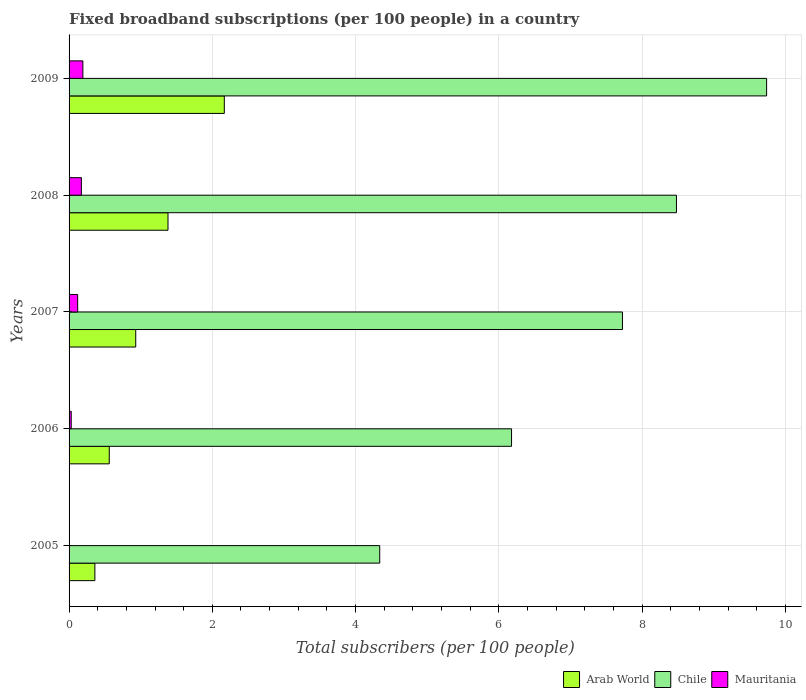Are the number of bars on each tick of the Y-axis equal?
Offer a terse response. Yes. What is the label of the 4th group of bars from the top?
Keep it short and to the point. 2006. What is the number of broadband subscriptions in Mauritania in 2007?
Provide a succinct answer. 0.12. Across all years, what is the maximum number of broadband subscriptions in Arab World?
Your response must be concise. 2.17. Across all years, what is the minimum number of broadband subscriptions in Mauritania?
Your answer should be very brief. 0.01. In which year was the number of broadband subscriptions in Mauritania maximum?
Offer a terse response. 2009. What is the total number of broadband subscriptions in Arab World in the graph?
Keep it short and to the point. 5.4. What is the difference between the number of broadband subscriptions in Mauritania in 2005 and that in 2009?
Make the answer very short. -0.19. What is the difference between the number of broadband subscriptions in Mauritania in 2008 and the number of broadband subscriptions in Arab World in 2007?
Provide a succinct answer. -0.76. What is the average number of broadband subscriptions in Mauritania per year?
Keep it short and to the point. 0.1. In the year 2009, what is the difference between the number of broadband subscriptions in Mauritania and number of broadband subscriptions in Arab World?
Keep it short and to the point. -1.97. In how many years, is the number of broadband subscriptions in Mauritania greater than 8.8 ?
Your answer should be very brief. 0. What is the ratio of the number of broadband subscriptions in Mauritania in 2007 to that in 2009?
Your answer should be compact. 0.62. Is the number of broadband subscriptions in Mauritania in 2006 less than that in 2007?
Provide a short and direct response. Yes. What is the difference between the highest and the second highest number of broadband subscriptions in Mauritania?
Provide a succinct answer. 0.02. What is the difference between the highest and the lowest number of broadband subscriptions in Chile?
Offer a terse response. 5.4. In how many years, is the number of broadband subscriptions in Chile greater than the average number of broadband subscriptions in Chile taken over all years?
Offer a terse response. 3. What does the 1st bar from the top in 2009 represents?
Make the answer very short. Mauritania. What does the 2nd bar from the bottom in 2006 represents?
Give a very brief answer. Chile. Is it the case that in every year, the sum of the number of broadband subscriptions in Arab World and number of broadband subscriptions in Chile is greater than the number of broadband subscriptions in Mauritania?
Offer a terse response. Yes. How many bars are there?
Your answer should be very brief. 15. How many years are there in the graph?
Your answer should be compact. 5. What is the difference between two consecutive major ticks on the X-axis?
Your answer should be compact. 2. Are the values on the major ticks of X-axis written in scientific E-notation?
Provide a short and direct response. No. How many legend labels are there?
Provide a short and direct response. 3. How are the legend labels stacked?
Give a very brief answer. Horizontal. What is the title of the graph?
Your response must be concise. Fixed broadband subscriptions (per 100 people) in a country. What is the label or title of the X-axis?
Offer a terse response. Total subscribers (per 100 people). What is the Total subscribers (per 100 people) in Arab World in 2005?
Your answer should be compact. 0.36. What is the Total subscribers (per 100 people) of Chile in 2005?
Your answer should be compact. 4.34. What is the Total subscribers (per 100 people) of Mauritania in 2005?
Ensure brevity in your answer.  0.01. What is the Total subscribers (per 100 people) of Arab World in 2006?
Keep it short and to the point. 0.56. What is the Total subscribers (per 100 people) in Chile in 2006?
Your response must be concise. 6.18. What is the Total subscribers (per 100 people) of Mauritania in 2006?
Provide a short and direct response. 0.03. What is the Total subscribers (per 100 people) in Arab World in 2007?
Give a very brief answer. 0.93. What is the Total subscribers (per 100 people) in Chile in 2007?
Ensure brevity in your answer.  7.73. What is the Total subscribers (per 100 people) of Mauritania in 2007?
Keep it short and to the point. 0.12. What is the Total subscribers (per 100 people) of Arab World in 2008?
Provide a succinct answer. 1.38. What is the Total subscribers (per 100 people) of Chile in 2008?
Provide a short and direct response. 8.48. What is the Total subscribers (per 100 people) in Mauritania in 2008?
Offer a terse response. 0.17. What is the Total subscribers (per 100 people) in Arab World in 2009?
Your answer should be compact. 2.17. What is the Total subscribers (per 100 people) in Chile in 2009?
Provide a short and direct response. 9.74. What is the Total subscribers (per 100 people) of Mauritania in 2009?
Make the answer very short. 0.19. Across all years, what is the maximum Total subscribers (per 100 people) of Arab World?
Your response must be concise. 2.17. Across all years, what is the maximum Total subscribers (per 100 people) of Chile?
Your response must be concise. 9.74. Across all years, what is the maximum Total subscribers (per 100 people) of Mauritania?
Your answer should be very brief. 0.19. Across all years, what is the minimum Total subscribers (per 100 people) in Arab World?
Offer a terse response. 0.36. Across all years, what is the minimum Total subscribers (per 100 people) of Chile?
Provide a short and direct response. 4.34. Across all years, what is the minimum Total subscribers (per 100 people) in Mauritania?
Your answer should be compact. 0.01. What is the total Total subscribers (per 100 people) in Arab World in the graph?
Keep it short and to the point. 5.4. What is the total Total subscribers (per 100 people) of Chile in the graph?
Provide a short and direct response. 36.46. What is the total Total subscribers (per 100 people) of Mauritania in the graph?
Your answer should be very brief. 0.52. What is the difference between the Total subscribers (per 100 people) in Arab World in 2005 and that in 2006?
Make the answer very short. -0.2. What is the difference between the Total subscribers (per 100 people) of Chile in 2005 and that in 2006?
Your answer should be very brief. -1.84. What is the difference between the Total subscribers (per 100 people) of Mauritania in 2005 and that in 2006?
Provide a short and direct response. -0.02. What is the difference between the Total subscribers (per 100 people) of Arab World in 2005 and that in 2007?
Your response must be concise. -0.57. What is the difference between the Total subscribers (per 100 people) in Chile in 2005 and that in 2007?
Give a very brief answer. -3.39. What is the difference between the Total subscribers (per 100 people) of Mauritania in 2005 and that in 2007?
Give a very brief answer. -0.11. What is the difference between the Total subscribers (per 100 people) in Arab World in 2005 and that in 2008?
Offer a very short reply. -1.02. What is the difference between the Total subscribers (per 100 people) in Chile in 2005 and that in 2008?
Your answer should be very brief. -4.14. What is the difference between the Total subscribers (per 100 people) of Mauritania in 2005 and that in 2008?
Offer a very short reply. -0.17. What is the difference between the Total subscribers (per 100 people) in Arab World in 2005 and that in 2009?
Ensure brevity in your answer.  -1.81. What is the difference between the Total subscribers (per 100 people) of Chile in 2005 and that in 2009?
Give a very brief answer. -5.4. What is the difference between the Total subscribers (per 100 people) in Mauritania in 2005 and that in 2009?
Provide a short and direct response. -0.19. What is the difference between the Total subscribers (per 100 people) of Arab World in 2006 and that in 2007?
Keep it short and to the point. -0.37. What is the difference between the Total subscribers (per 100 people) in Chile in 2006 and that in 2007?
Keep it short and to the point. -1.55. What is the difference between the Total subscribers (per 100 people) of Mauritania in 2006 and that in 2007?
Offer a terse response. -0.09. What is the difference between the Total subscribers (per 100 people) of Arab World in 2006 and that in 2008?
Make the answer very short. -0.82. What is the difference between the Total subscribers (per 100 people) of Chile in 2006 and that in 2008?
Your answer should be very brief. -2.3. What is the difference between the Total subscribers (per 100 people) of Mauritania in 2006 and that in 2008?
Keep it short and to the point. -0.14. What is the difference between the Total subscribers (per 100 people) in Arab World in 2006 and that in 2009?
Your answer should be very brief. -1.61. What is the difference between the Total subscribers (per 100 people) of Chile in 2006 and that in 2009?
Offer a terse response. -3.56. What is the difference between the Total subscribers (per 100 people) in Mauritania in 2006 and that in 2009?
Provide a short and direct response. -0.16. What is the difference between the Total subscribers (per 100 people) of Arab World in 2007 and that in 2008?
Your answer should be compact. -0.45. What is the difference between the Total subscribers (per 100 people) of Chile in 2007 and that in 2008?
Provide a short and direct response. -0.75. What is the difference between the Total subscribers (per 100 people) of Mauritania in 2007 and that in 2008?
Make the answer very short. -0.05. What is the difference between the Total subscribers (per 100 people) in Arab World in 2007 and that in 2009?
Ensure brevity in your answer.  -1.24. What is the difference between the Total subscribers (per 100 people) of Chile in 2007 and that in 2009?
Offer a very short reply. -2.01. What is the difference between the Total subscribers (per 100 people) in Mauritania in 2007 and that in 2009?
Provide a succinct answer. -0.07. What is the difference between the Total subscribers (per 100 people) in Arab World in 2008 and that in 2009?
Ensure brevity in your answer.  -0.79. What is the difference between the Total subscribers (per 100 people) in Chile in 2008 and that in 2009?
Offer a very short reply. -1.26. What is the difference between the Total subscribers (per 100 people) in Mauritania in 2008 and that in 2009?
Ensure brevity in your answer.  -0.02. What is the difference between the Total subscribers (per 100 people) in Arab World in 2005 and the Total subscribers (per 100 people) in Chile in 2006?
Your response must be concise. -5.82. What is the difference between the Total subscribers (per 100 people) of Arab World in 2005 and the Total subscribers (per 100 people) of Mauritania in 2006?
Your response must be concise. 0.33. What is the difference between the Total subscribers (per 100 people) of Chile in 2005 and the Total subscribers (per 100 people) of Mauritania in 2006?
Provide a succinct answer. 4.31. What is the difference between the Total subscribers (per 100 people) of Arab World in 2005 and the Total subscribers (per 100 people) of Chile in 2007?
Keep it short and to the point. -7.37. What is the difference between the Total subscribers (per 100 people) in Arab World in 2005 and the Total subscribers (per 100 people) in Mauritania in 2007?
Offer a very short reply. 0.24. What is the difference between the Total subscribers (per 100 people) of Chile in 2005 and the Total subscribers (per 100 people) of Mauritania in 2007?
Make the answer very short. 4.22. What is the difference between the Total subscribers (per 100 people) of Arab World in 2005 and the Total subscribers (per 100 people) of Chile in 2008?
Provide a short and direct response. -8.12. What is the difference between the Total subscribers (per 100 people) of Arab World in 2005 and the Total subscribers (per 100 people) of Mauritania in 2008?
Provide a short and direct response. 0.19. What is the difference between the Total subscribers (per 100 people) in Chile in 2005 and the Total subscribers (per 100 people) in Mauritania in 2008?
Your answer should be compact. 4.17. What is the difference between the Total subscribers (per 100 people) of Arab World in 2005 and the Total subscribers (per 100 people) of Chile in 2009?
Give a very brief answer. -9.38. What is the difference between the Total subscribers (per 100 people) of Arab World in 2005 and the Total subscribers (per 100 people) of Mauritania in 2009?
Your answer should be compact. 0.17. What is the difference between the Total subscribers (per 100 people) of Chile in 2005 and the Total subscribers (per 100 people) of Mauritania in 2009?
Make the answer very short. 4.14. What is the difference between the Total subscribers (per 100 people) of Arab World in 2006 and the Total subscribers (per 100 people) of Chile in 2007?
Provide a short and direct response. -7.16. What is the difference between the Total subscribers (per 100 people) in Arab World in 2006 and the Total subscribers (per 100 people) in Mauritania in 2007?
Make the answer very short. 0.44. What is the difference between the Total subscribers (per 100 people) of Chile in 2006 and the Total subscribers (per 100 people) of Mauritania in 2007?
Keep it short and to the point. 6.06. What is the difference between the Total subscribers (per 100 people) of Arab World in 2006 and the Total subscribers (per 100 people) of Chile in 2008?
Ensure brevity in your answer.  -7.92. What is the difference between the Total subscribers (per 100 people) in Arab World in 2006 and the Total subscribers (per 100 people) in Mauritania in 2008?
Your answer should be compact. 0.39. What is the difference between the Total subscribers (per 100 people) of Chile in 2006 and the Total subscribers (per 100 people) of Mauritania in 2008?
Offer a very short reply. 6.01. What is the difference between the Total subscribers (per 100 people) in Arab World in 2006 and the Total subscribers (per 100 people) in Chile in 2009?
Your answer should be compact. -9.18. What is the difference between the Total subscribers (per 100 people) in Arab World in 2006 and the Total subscribers (per 100 people) in Mauritania in 2009?
Your response must be concise. 0.37. What is the difference between the Total subscribers (per 100 people) of Chile in 2006 and the Total subscribers (per 100 people) of Mauritania in 2009?
Your response must be concise. 5.98. What is the difference between the Total subscribers (per 100 people) of Arab World in 2007 and the Total subscribers (per 100 people) of Chile in 2008?
Keep it short and to the point. -7.55. What is the difference between the Total subscribers (per 100 people) in Arab World in 2007 and the Total subscribers (per 100 people) in Mauritania in 2008?
Make the answer very short. 0.76. What is the difference between the Total subscribers (per 100 people) in Chile in 2007 and the Total subscribers (per 100 people) in Mauritania in 2008?
Your answer should be very brief. 7.55. What is the difference between the Total subscribers (per 100 people) of Arab World in 2007 and the Total subscribers (per 100 people) of Chile in 2009?
Ensure brevity in your answer.  -8.81. What is the difference between the Total subscribers (per 100 people) of Arab World in 2007 and the Total subscribers (per 100 people) of Mauritania in 2009?
Give a very brief answer. 0.74. What is the difference between the Total subscribers (per 100 people) in Chile in 2007 and the Total subscribers (per 100 people) in Mauritania in 2009?
Ensure brevity in your answer.  7.53. What is the difference between the Total subscribers (per 100 people) of Arab World in 2008 and the Total subscribers (per 100 people) of Chile in 2009?
Give a very brief answer. -8.36. What is the difference between the Total subscribers (per 100 people) in Arab World in 2008 and the Total subscribers (per 100 people) in Mauritania in 2009?
Provide a short and direct response. 1.19. What is the difference between the Total subscribers (per 100 people) of Chile in 2008 and the Total subscribers (per 100 people) of Mauritania in 2009?
Your answer should be compact. 8.29. What is the average Total subscribers (per 100 people) in Arab World per year?
Your answer should be compact. 1.08. What is the average Total subscribers (per 100 people) of Chile per year?
Provide a short and direct response. 7.29. What is the average Total subscribers (per 100 people) in Mauritania per year?
Ensure brevity in your answer.  0.1. In the year 2005, what is the difference between the Total subscribers (per 100 people) of Arab World and Total subscribers (per 100 people) of Chile?
Keep it short and to the point. -3.98. In the year 2005, what is the difference between the Total subscribers (per 100 people) in Arab World and Total subscribers (per 100 people) in Mauritania?
Offer a terse response. 0.35. In the year 2005, what is the difference between the Total subscribers (per 100 people) of Chile and Total subscribers (per 100 people) of Mauritania?
Keep it short and to the point. 4.33. In the year 2006, what is the difference between the Total subscribers (per 100 people) of Arab World and Total subscribers (per 100 people) of Chile?
Offer a terse response. -5.62. In the year 2006, what is the difference between the Total subscribers (per 100 people) of Arab World and Total subscribers (per 100 people) of Mauritania?
Give a very brief answer. 0.53. In the year 2006, what is the difference between the Total subscribers (per 100 people) in Chile and Total subscribers (per 100 people) in Mauritania?
Offer a very short reply. 6.15. In the year 2007, what is the difference between the Total subscribers (per 100 people) in Arab World and Total subscribers (per 100 people) in Chile?
Offer a terse response. -6.8. In the year 2007, what is the difference between the Total subscribers (per 100 people) of Arab World and Total subscribers (per 100 people) of Mauritania?
Make the answer very short. 0.81. In the year 2007, what is the difference between the Total subscribers (per 100 people) of Chile and Total subscribers (per 100 people) of Mauritania?
Provide a succinct answer. 7.61. In the year 2008, what is the difference between the Total subscribers (per 100 people) in Arab World and Total subscribers (per 100 people) in Chile?
Ensure brevity in your answer.  -7.1. In the year 2008, what is the difference between the Total subscribers (per 100 people) of Arab World and Total subscribers (per 100 people) of Mauritania?
Offer a very short reply. 1.21. In the year 2008, what is the difference between the Total subscribers (per 100 people) in Chile and Total subscribers (per 100 people) in Mauritania?
Your response must be concise. 8.31. In the year 2009, what is the difference between the Total subscribers (per 100 people) of Arab World and Total subscribers (per 100 people) of Chile?
Your answer should be compact. -7.57. In the year 2009, what is the difference between the Total subscribers (per 100 people) in Arab World and Total subscribers (per 100 people) in Mauritania?
Ensure brevity in your answer.  1.97. In the year 2009, what is the difference between the Total subscribers (per 100 people) of Chile and Total subscribers (per 100 people) of Mauritania?
Provide a succinct answer. 9.55. What is the ratio of the Total subscribers (per 100 people) of Arab World in 2005 to that in 2006?
Keep it short and to the point. 0.64. What is the ratio of the Total subscribers (per 100 people) in Chile in 2005 to that in 2006?
Provide a short and direct response. 0.7. What is the ratio of the Total subscribers (per 100 people) in Mauritania in 2005 to that in 2006?
Ensure brevity in your answer.  0.17. What is the ratio of the Total subscribers (per 100 people) of Arab World in 2005 to that in 2007?
Provide a short and direct response. 0.39. What is the ratio of the Total subscribers (per 100 people) in Chile in 2005 to that in 2007?
Offer a terse response. 0.56. What is the ratio of the Total subscribers (per 100 people) of Mauritania in 2005 to that in 2007?
Your response must be concise. 0.04. What is the ratio of the Total subscribers (per 100 people) of Arab World in 2005 to that in 2008?
Keep it short and to the point. 0.26. What is the ratio of the Total subscribers (per 100 people) in Chile in 2005 to that in 2008?
Provide a succinct answer. 0.51. What is the ratio of the Total subscribers (per 100 people) in Mauritania in 2005 to that in 2008?
Offer a very short reply. 0.03. What is the ratio of the Total subscribers (per 100 people) of Arab World in 2005 to that in 2009?
Your answer should be very brief. 0.17. What is the ratio of the Total subscribers (per 100 people) in Chile in 2005 to that in 2009?
Provide a succinct answer. 0.45. What is the ratio of the Total subscribers (per 100 people) in Mauritania in 2005 to that in 2009?
Your answer should be very brief. 0.03. What is the ratio of the Total subscribers (per 100 people) of Arab World in 2006 to that in 2007?
Keep it short and to the point. 0.6. What is the ratio of the Total subscribers (per 100 people) of Chile in 2006 to that in 2007?
Ensure brevity in your answer.  0.8. What is the ratio of the Total subscribers (per 100 people) in Mauritania in 2006 to that in 2007?
Your answer should be very brief. 0.25. What is the ratio of the Total subscribers (per 100 people) in Arab World in 2006 to that in 2008?
Your response must be concise. 0.41. What is the ratio of the Total subscribers (per 100 people) of Chile in 2006 to that in 2008?
Offer a very short reply. 0.73. What is the ratio of the Total subscribers (per 100 people) in Mauritania in 2006 to that in 2008?
Make the answer very short. 0.18. What is the ratio of the Total subscribers (per 100 people) of Arab World in 2006 to that in 2009?
Provide a succinct answer. 0.26. What is the ratio of the Total subscribers (per 100 people) in Chile in 2006 to that in 2009?
Keep it short and to the point. 0.63. What is the ratio of the Total subscribers (per 100 people) in Mauritania in 2006 to that in 2009?
Ensure brevity in your answer.  0.16. What is the ratio of the Total subscribers (per 100 people) in Arab World in 2007 to that in 2008?
Your answer should be compact. 0.67. What is the ratio of the Total subscribers (per 100 people) of Chile in 2007 to that in 2008?
Your answer should be very brief. 0.91. What is the ratio of the Total subscribers (per 100 people) in Mauritania in 2007 to that in 2008?
Offer a very short reply. 0.7. What is the ratio of the Total subscribers (per 100 people) in Arab World in 2007 to that in 2009?
Keep it short and to the point. 0.43. What is the ratio of the Total subscribers (per 100 people) in Chile in 2007 to that in 2009?
Offer a terse response. 0.79. What is the ratio of the Total subscribers (per 100 people) of Mauritania in 2007 to that in 2009?
Your answer should be compact. 0.62. What is the ratio of the Total subscribers (per 100 people) of Arab World in 2008 to that in 2009?
Provide a succinct answer. 0.64. What is the ratio of the Total subscribers (per 100 people) of Chile in 2008 to that in 2009?
Your answer should be very brief. 0.87. What is the ratio of the Total subscribers (per 100 people) of Mauritania in 2008 to that in 2009?
Your response must be concise. 0.89. What is the difference between the highest and the second highest Total subscribers (per 100 people) of Arab World?
Provide a short and direct response. 0.79. What is the difference between the highest and the second highest Total subscribers (per 100 people) of Chile?
Your answer should be very brief. 1.26. What is the difference between the highest and the second highest Total subscribers (per 100 people) of Mauritania?
Make the answer very short. 0.02. What is the difference between the highest and the lowest Total subscribers (per 100 people) in Arab World?
Offer a very short reply. 1.81. What is the difference between the highest and the lowest Total subscribers (per 100 people) in Chile?
Offer a terse response. 5.4. What is the difference between the highest and the lowest Total subscribers (per 100 people) in Mauritania?
Offer a terse response. 0.19. 